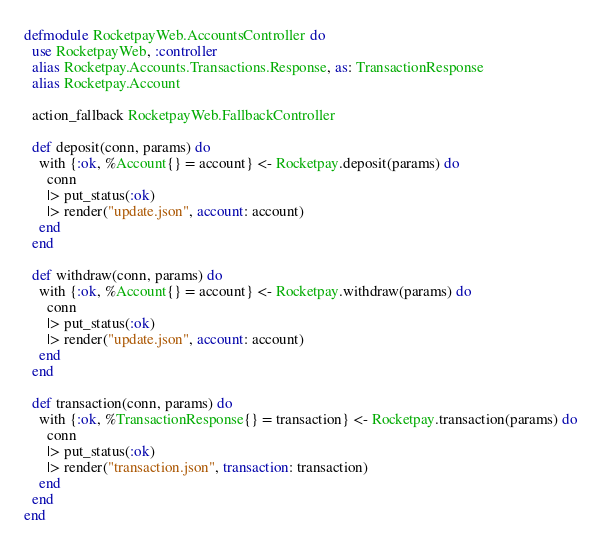<code> <loc_0><loc_0><loc_500><loc_500><_Elixir_>defmodule RocketpayWeb.AccountsController do
  use RocketpayWeb, :controller
  alias Rocketpay.Accounts.Transactions.Response, as: TransactionResponse
  alias Rocketpay.Account

  action_fallback RocketpayWeb.FallbackController

  def deposit(conn, params) do
    with {:ok, %Account{} = account} <- Rocketpay.deposit(params) do
      conn
      |> put_status(:ok)
      |> render("update.json", account: account)
    end
  end

  def withdraw(conn, params) do
    with {:ok, %Account{} = account} <- Rocketpay.withdraw(params) do
      conn
      |> put_status(:ok)
      |> render("update.json", account: account)
    end
  end

  def transaction(conn, params) do
    with {:ok, %TransactionResponse{} = transaction} <- Rocketpay.transaction(params) do
      conn
      |> put_status(:ok)
      |> render("transaction.json", transaction: transaction)
    end
  end
end
</code> 